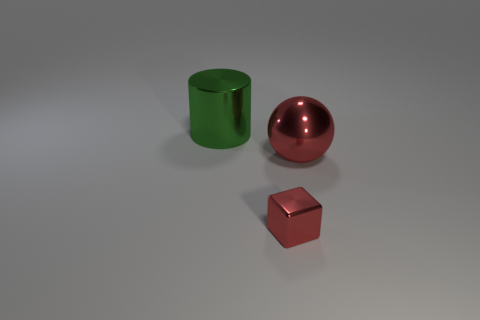Add 3 matte spheres. How many objects exist? 6 Subtract all spheres. How many objects are left? 2 Add 3 red shiny cubes. How many red shiny cubes are left? 4 Add 2 big cyan matte blocks. How many big cyan matte blocks exist? 2 Subtract 0 green spheres. How many objects are left? 3 Subtract all purple matte spheres. Subtract all big red shiny balls. How many objects are left? 2 